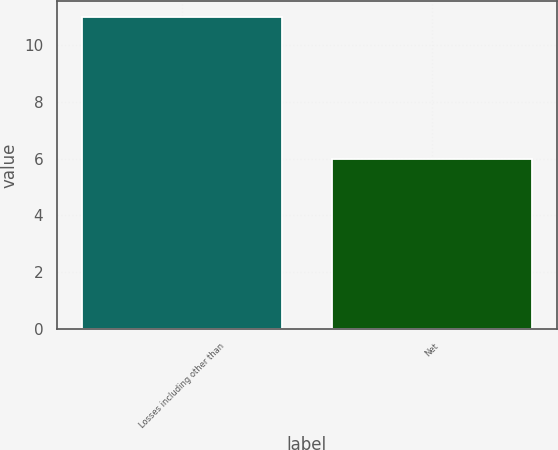Convert chart. <chart><loc_0><loc_0><loc_500><loc_500><bar_chart><fcel>Losses including other than<fcel>Net<nl><fcel>11<fcel>6<nl></chart> 